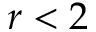Convert formula to latex. <formula><loc_0><loc_0><loc_500><loc_500>r < 2</formula> 